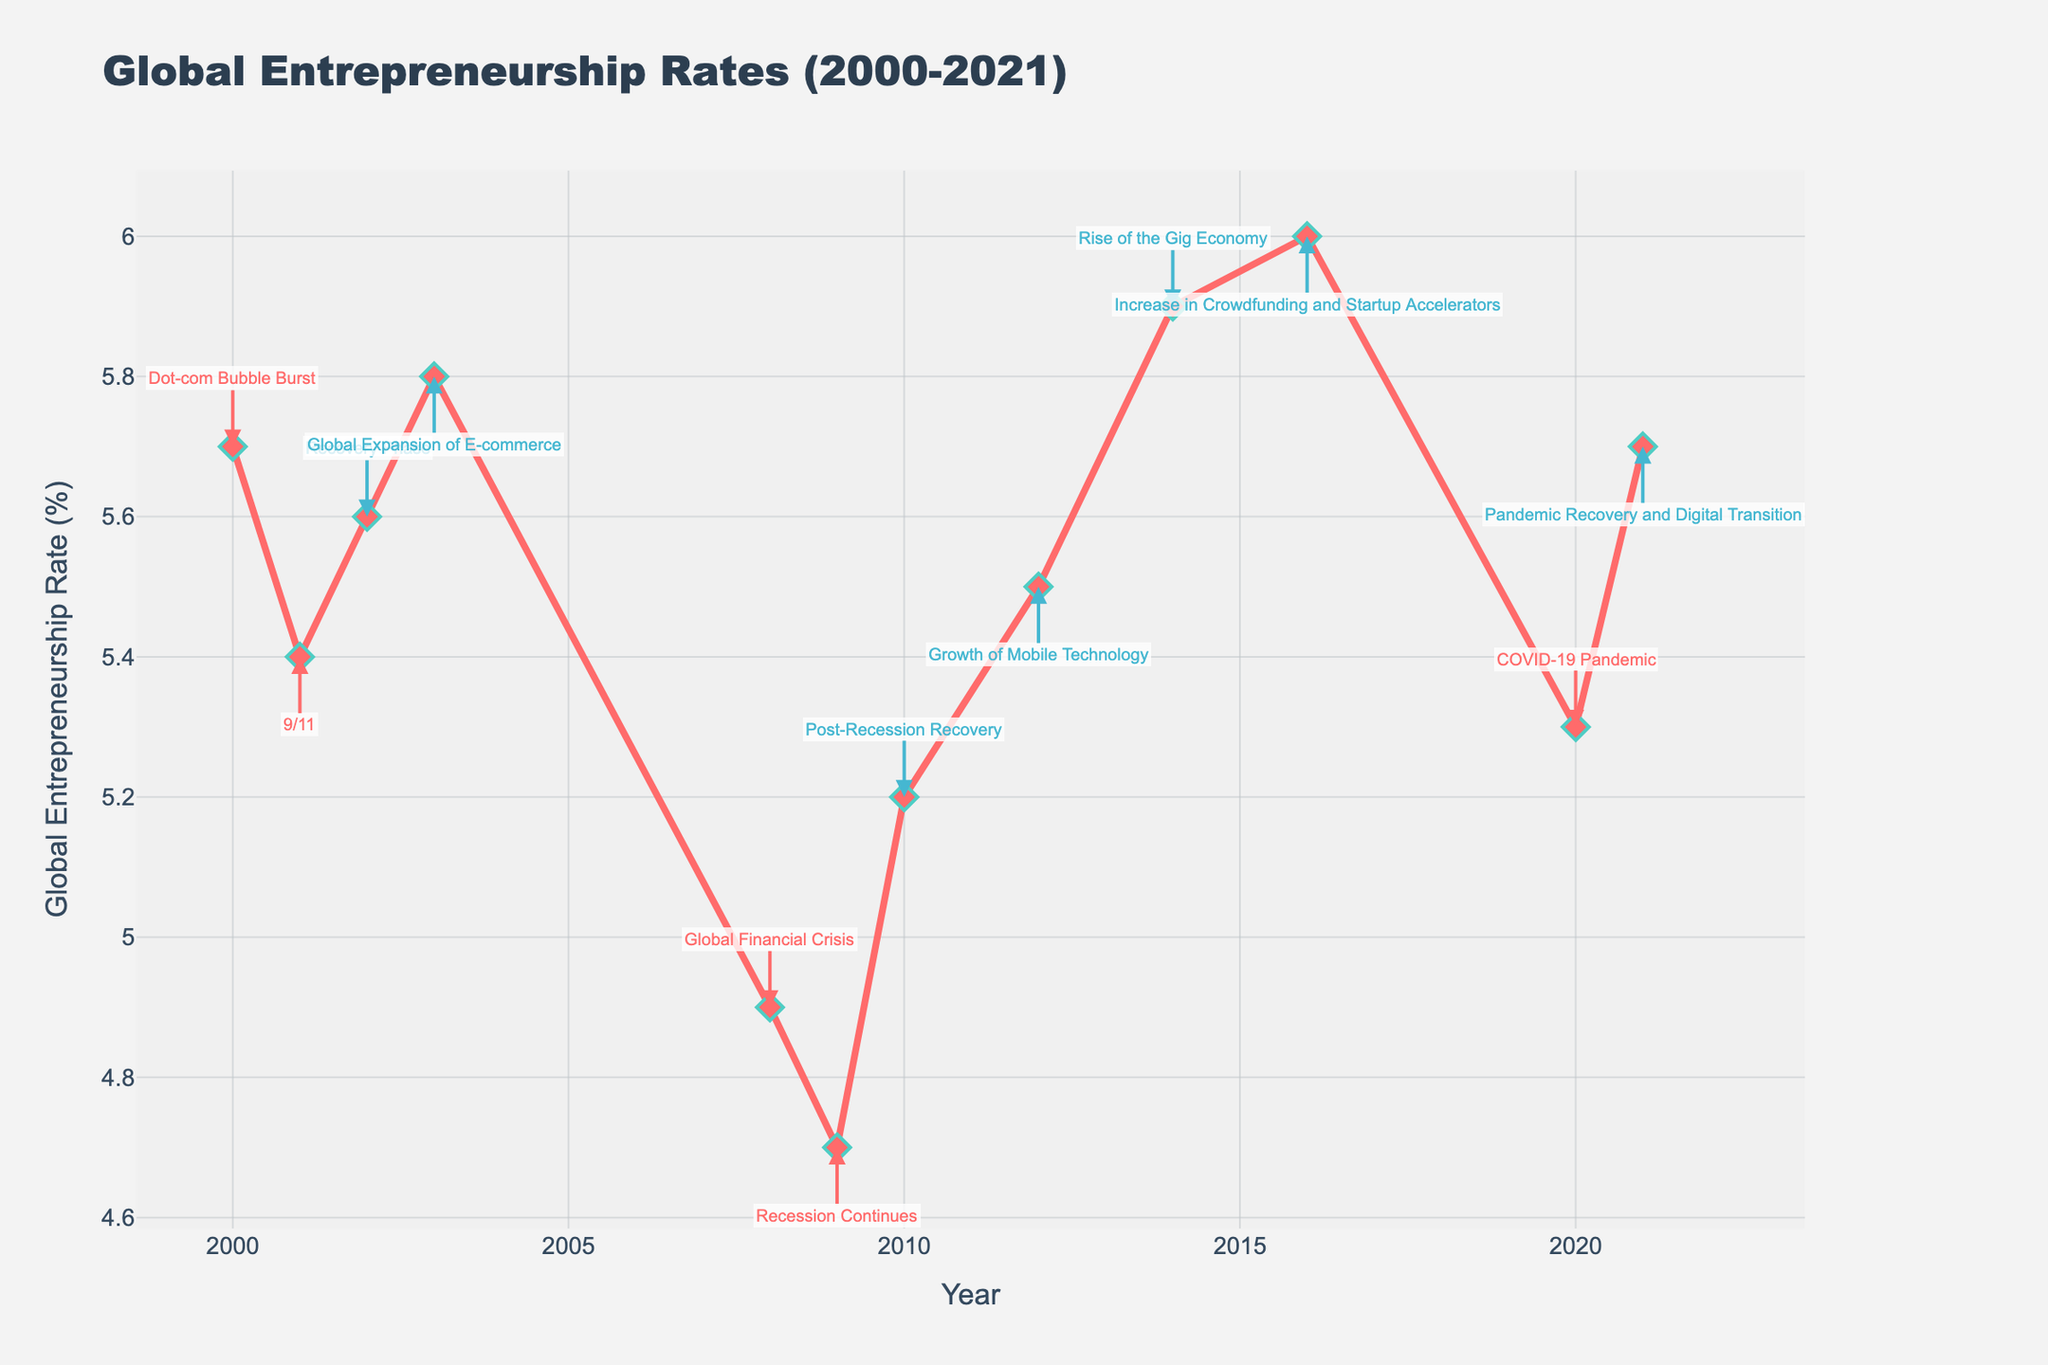What is the global entrepreneurship rate in 2000? By looking at the point corresponding to the year 2000 on the x-axis, we observe the y-value associated with it. The global entrepreneurship rate in 2000 is shown to be 5.7%.
Answer: 5.7% Which year shows a significant decline due to the Global Financial Crisis? Observing the plot, the significant decline is marked by an annotation "Global Financial Crisis". This corresponds to the year 2008. Following the annotation, we can see a decrease in the rate in that year.
Answer: 2008 How many years had a positive impact on entrepreneurship rates, according to the annotations? By counting the annotations on the plot with a positive impact (typically shown in a specific color, like blue), we can see they are: 2002, 2003, 2010, 2012, 2014, 2016, and 2021, which totals to 7 years.
Answer: 7 What was the trend in entrepreneurship rates between 2008 and 2010? Starting from 2008 to 2010, observing the plot points, the rate declines in 2008 (Global Financial Crisis), continues to decline in 2009 (Recession Continues), and then starts to recover in 2010 (Post-Recession Recovery).
Answer: Decline & then recovery Which year recorded the lowest global entrepreneurship rate, and what was the rate? Find the lowest point on the plot, which corresponds to the year 2009. The global entrepreneurship rate in 2009 is 4.7%.
Answer: 2009, 4.7% What key event occurred in 2016, and how did it impact the entrepreneurship rate? By looking at the annotation for the year 2016, we see "Increase in Crowdfunding and Startup Accelerators". The impact associated with this event is positive. Thus, in 2016, the key event is "Increase in Crowdfunding and Startup Accelerators" and the impact was positive.
Answer: Increase in Crowdfunding and Startup Accelerators, Positive Compare the entrepreneurship rates in 2001 and 2010, and describe the change. In 2001, the rate is 5.4%, and by 2010, it is 5.2%. Comparing these, the rate decreased by 0.2 percentage points from 2001 to 2010.
Answer: Decreased by 0.2 percentage points What was the global entrepreneurship rate just before the COVID-19 pandemic? The COVID-19 pandemic is labeled in the year 2020. Observing the year immediately preceding it, 2019, we check the rate for the year 2019. Since there is no specific rate listed for 2019 in the provided data, we infer the closest available data point for 2019 by noting the trend, which is 6.0% in 2016, subsequently declining in 2020.
Answer: (Closest available data point from 2016-2020 shows an increasing trend, the closest year 2016 is 6.0%) How did the global entrepreneurship rate change from the peak year to the year 2020? First, identify the peak year with the highest rate, which is 2016 with a rate of 6.0%. Then, check the rate for 2020, which is 5.3%. The change is 6.0% - 5.3% = 0.7 percentage points.
Answer: Decreased by 0.7 percentage points 